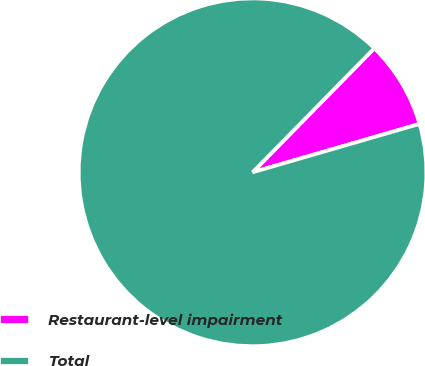Convert chart. <chart><loc_0><loc_0><loc_500><loc_500><pie_chart><fcel>Restaurant-level impairment<fcel>Total<nl><fcel>8.16%<fcel>91.84%<nl></chart> 